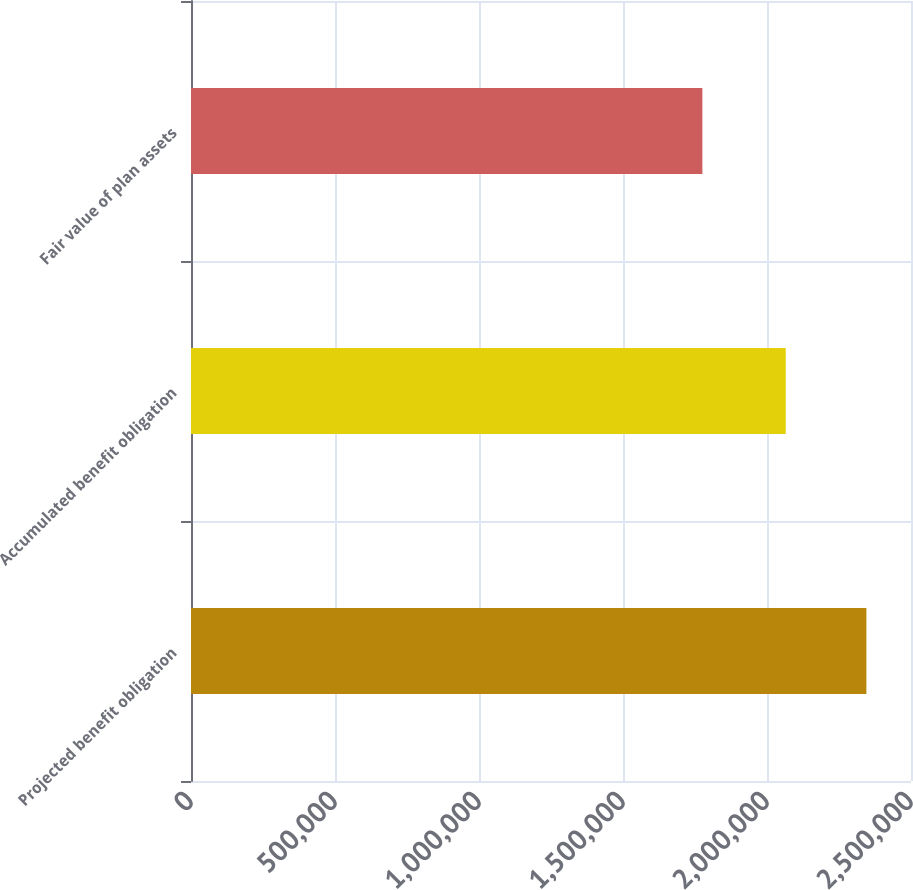<chart> <loc_0><loc_0><loc_500><loc_500><bar_chart><fcel>Projected benefit obligation<fcel>Accumulated benefit obligation<fcel>Fair value of plan assets<nl><fcel>2.34506e+06<fcel>2.06509e+06<fcel>1.7756e+06<nl></chart> 